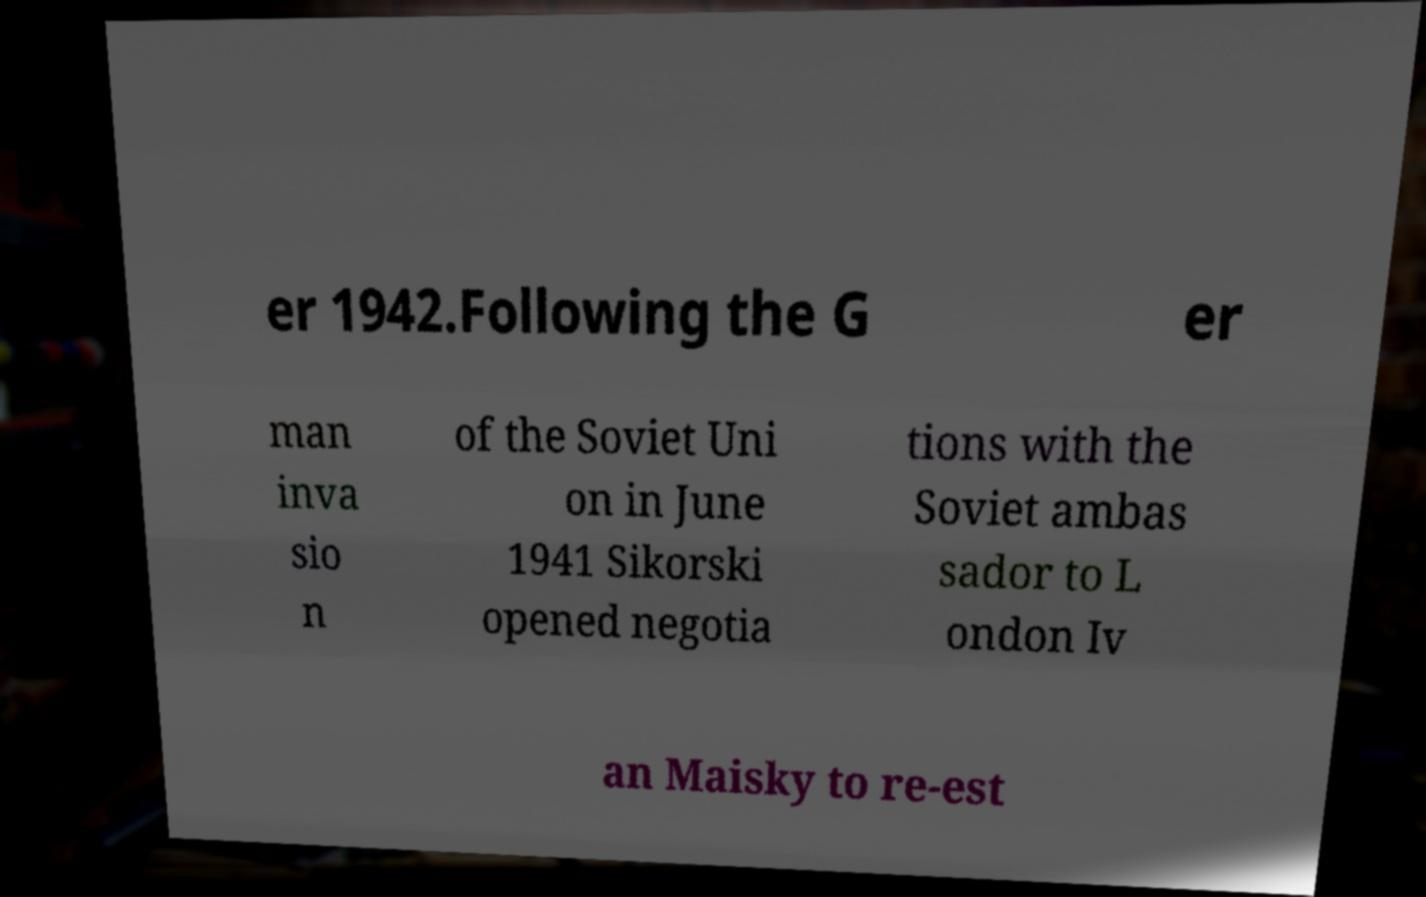For documentation purposes, I need the text within this image transcribed. Could you provide that? er 1942.Following the G er man inva sio n of the Soviet Uni on in June 1941 Sikorski opened negotia tions with the Soviet ambas sador to L ondon Iv an Maisky to re-est 